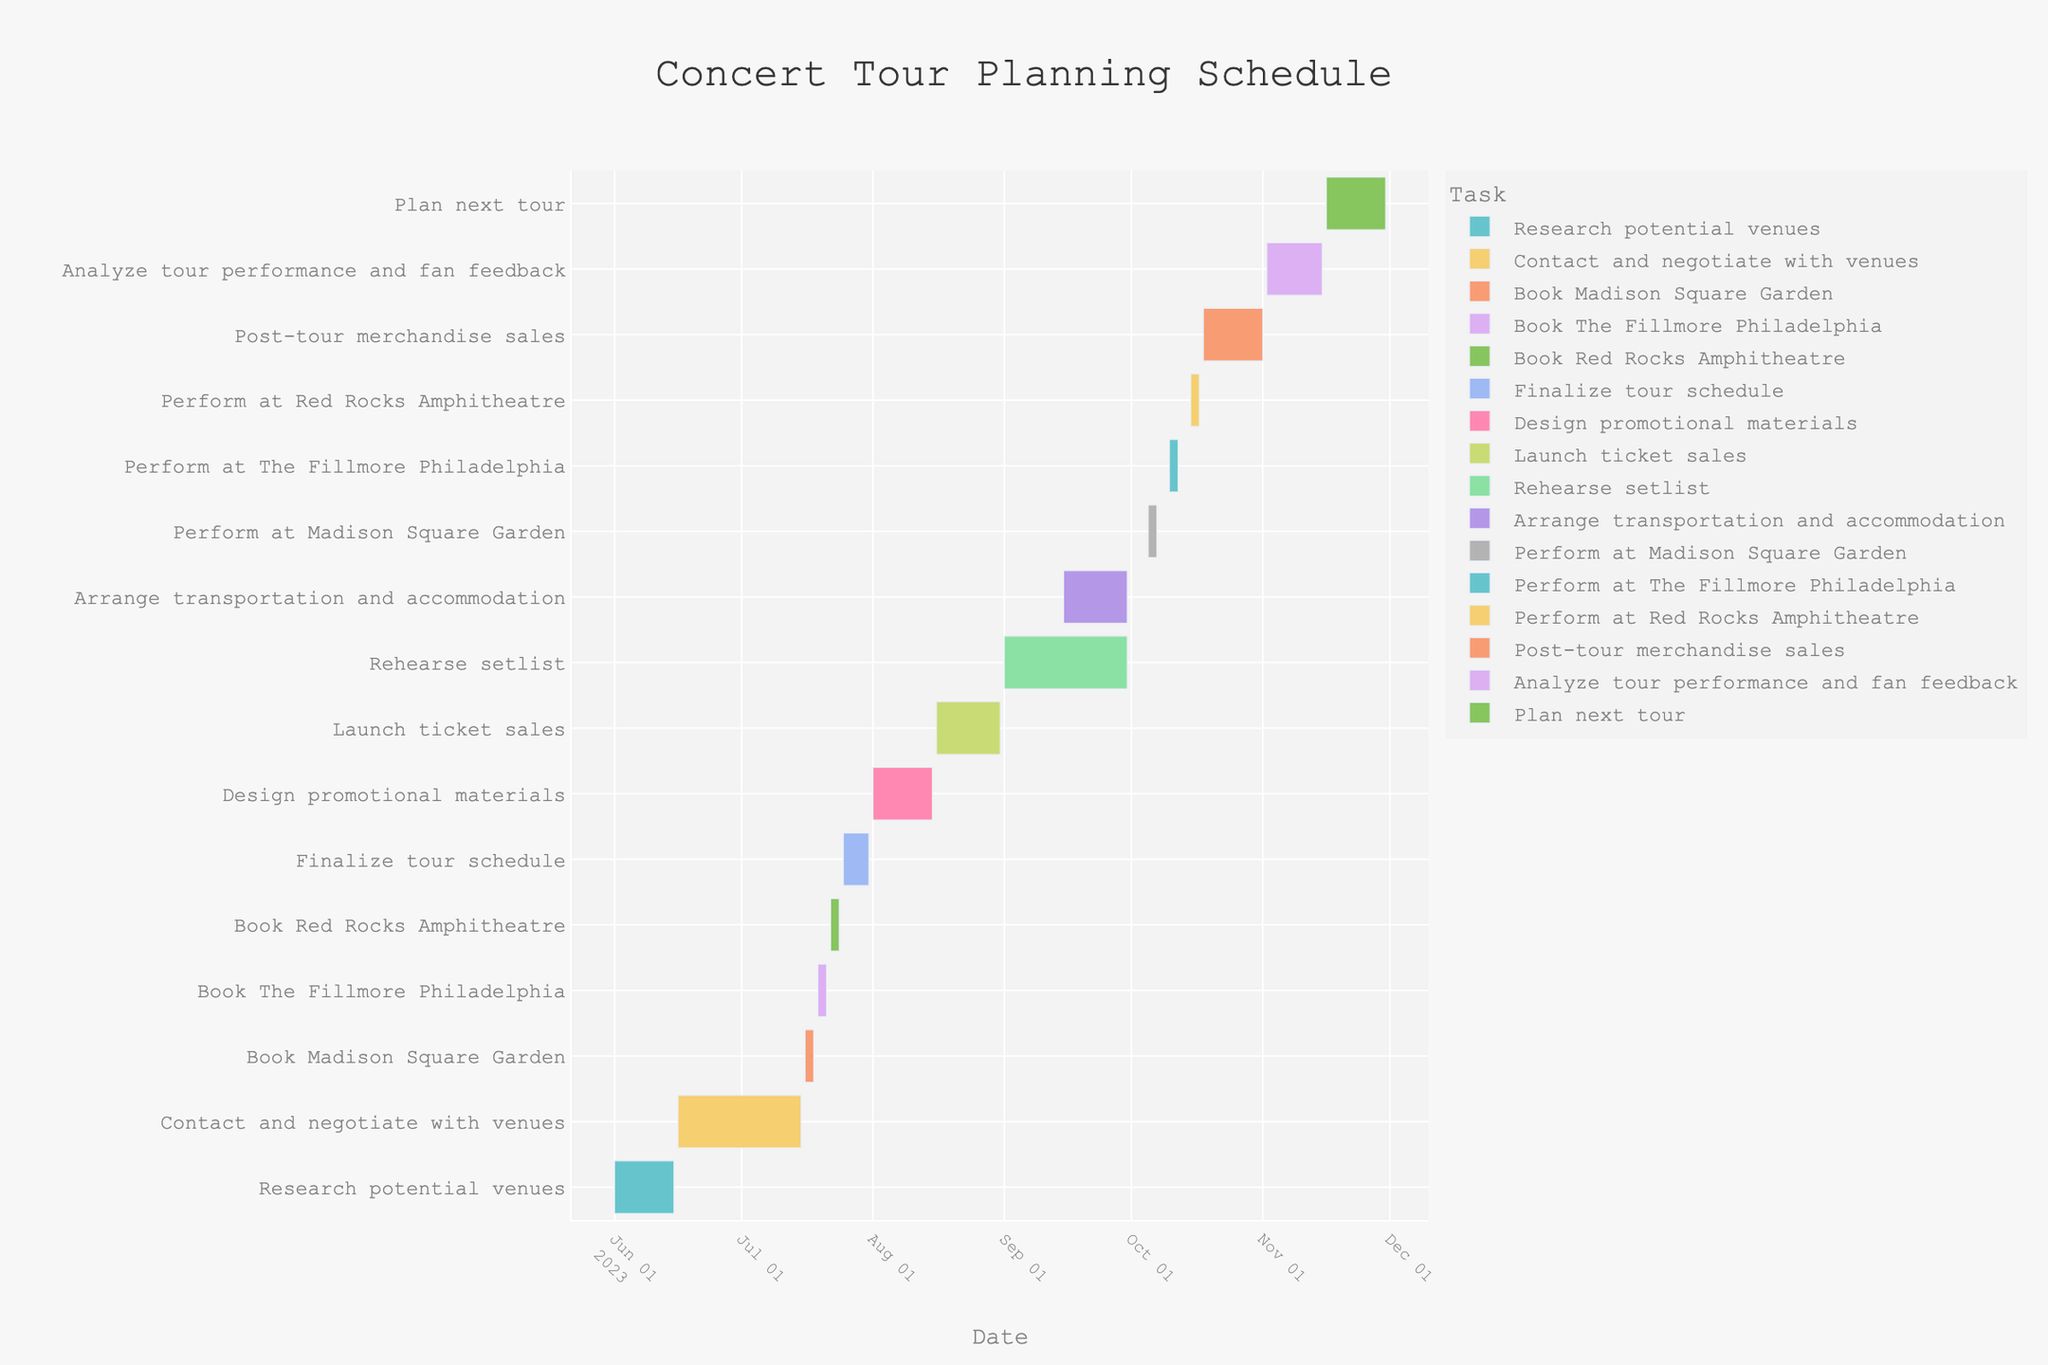What's the title of the Gantt chart? The title of the Gantt chart is prominently displayed at the top of the figure.
Answer: Concert Tour Planning Schedule When does the task "Design promotional materials" start and end? To find the start and end dates, locate the task "Design promotional materials" along the y-axis, then follow its corresponding horizontal bar to note the dates on the x-axis.
Answer: August 1, 2023 - August 15, 2023 What is the duration of the task "Rehearse setlist"? Identify the start and end dates for "Rehearse setlist" by checking its position in the chart. Calculate the duration by subtracting the start date from the end date.
Answer: 30 days Which task directly follows the booking of "Red Rocks Amphitheatre"? Identify the end date of "Book Red Rocks Amphitheatre" and look for the next task that starts immediately after that end date.
Answer: Finalize tour schedule What tasks are performed in October? Locate the month of October on the x-axis and identify all tasks with bars that fall within this month.
Answer: Perform at Madison Square Garden, Perform at The Fillmore Philadelphia, Perform at Red Rocks Amphitheatre, Post-tour merchandise sales How many days are there between contacting and negotiating with venues and the launch of ticket sales? Find the end date for "Contact and negotiate with venues" and the start date for "Launch ticket sales." Subtract the former from the latter.
Answer: 32 days How long is the gap between the end of "Rehearse setlist" and "Analyze tour performance and fan feedback"? Locate the end date of "Rehearse setlist" and the start date of "Analyze tour performance and fan feedback." Calculate the gap by finding the difference between these two dates.
Answer: 33 days Which task has the shortest duration, and what is it? Observe the lengths of all the tasks' horizontal bars and identify the shortest one.
Answer: Book Madison Square Garden, 3 days What two tasks overlap at the beginning of October? Identify tasks with horizontal bars that coincide in the first week of October.
Answer: Arrange transportation and accommodation, Perform at Madison Square Garden How many tasks are scheduled before August? Count all tasks with end dates before August by examining the corresponding bars' positions on the timeline.
Answer: 6 tasks 